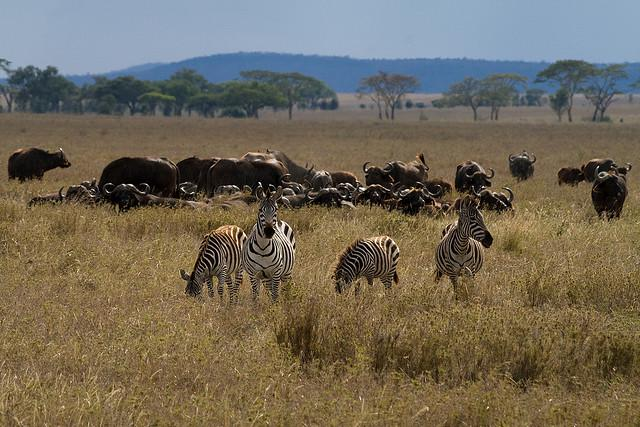How many zebras are standing in front of the pack of buffalo? four 